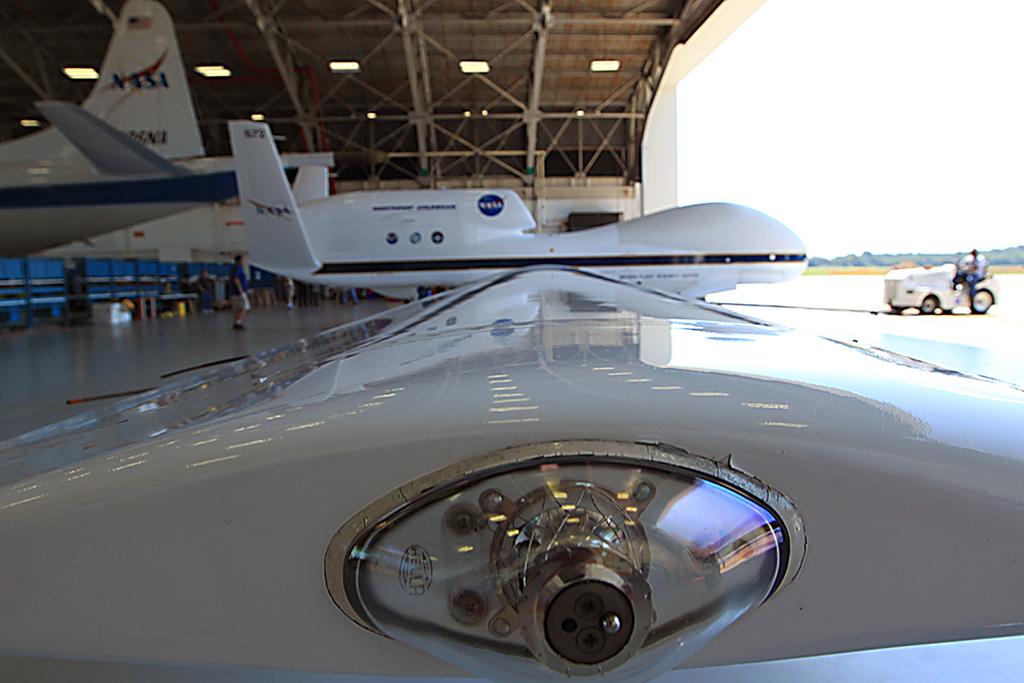What organization logo is on these planes?
Make the answer very short. Nasa. 